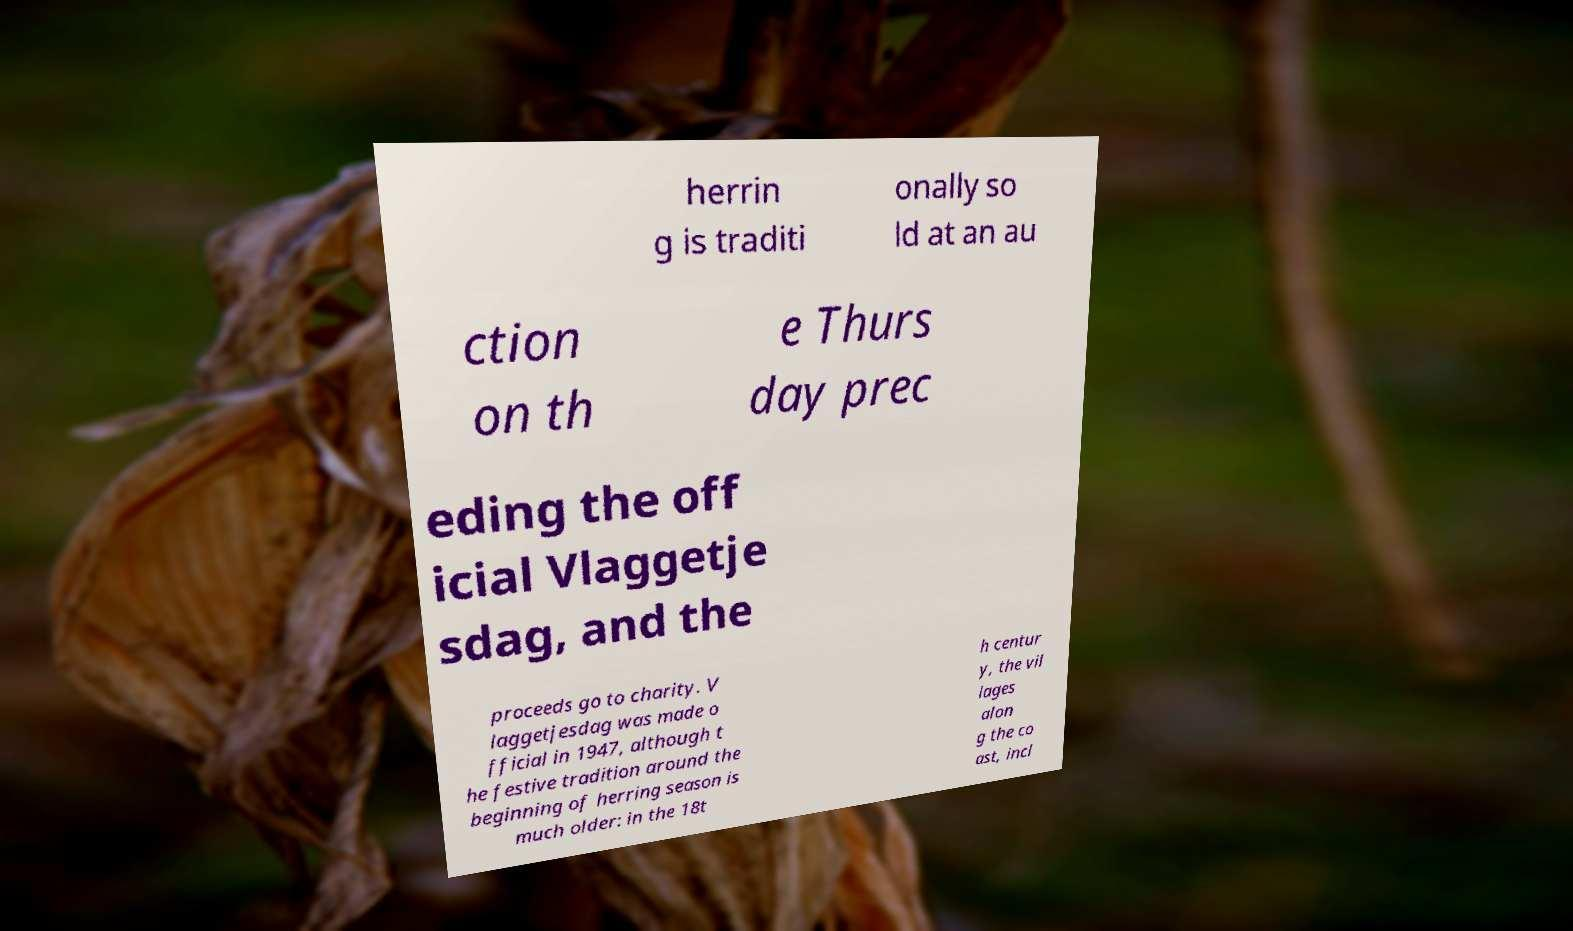Can you accurately transcribe the text from the provided image for me? herrin g is traditi onally so ld at an au ction on th e Thurs day prec eding the off icial Vlaggetje sdag, and the proceeds go to charity. V laggetjesdag was made o fficial in 1947, although t he festive tradition around the beginning of herring season is much older: in the 18t h centur y, the vil lages alon g the co ast, incl 